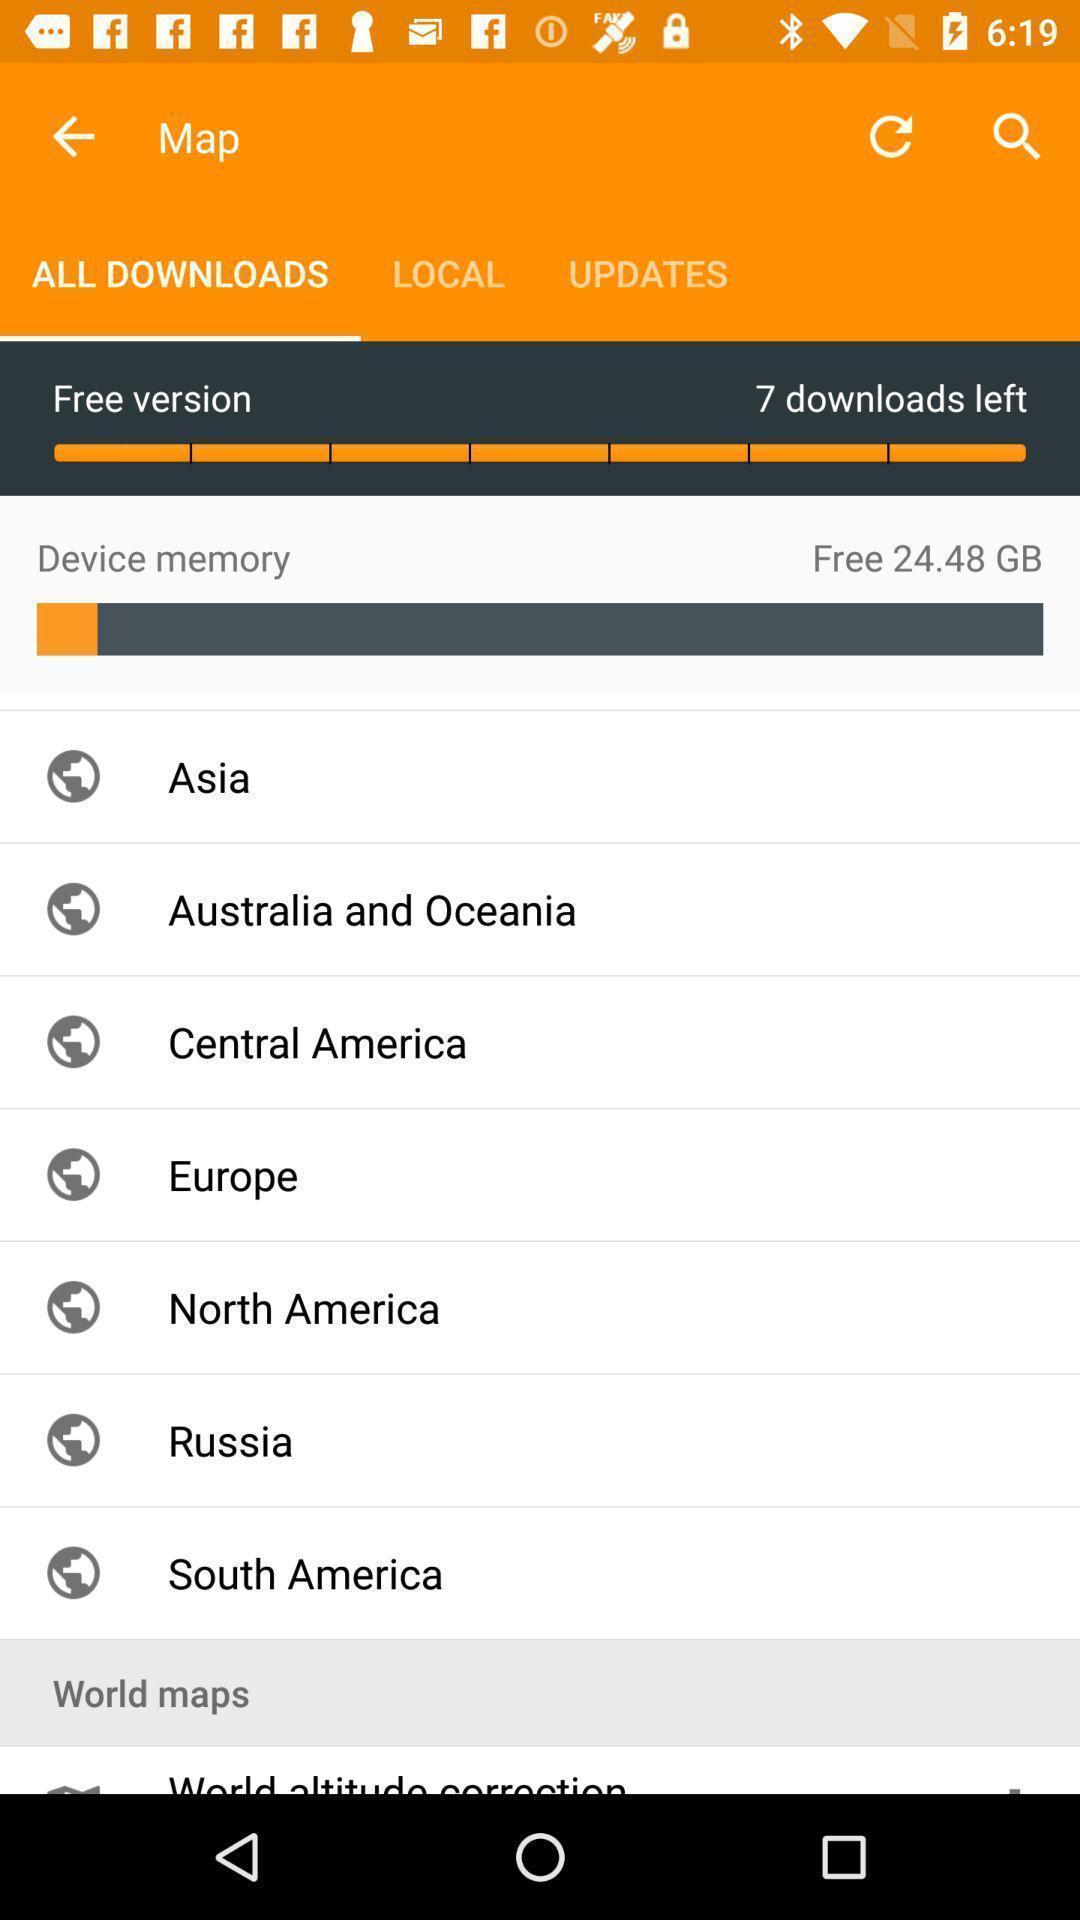Tell me what you see in this picture. Screen showing all downloads. 